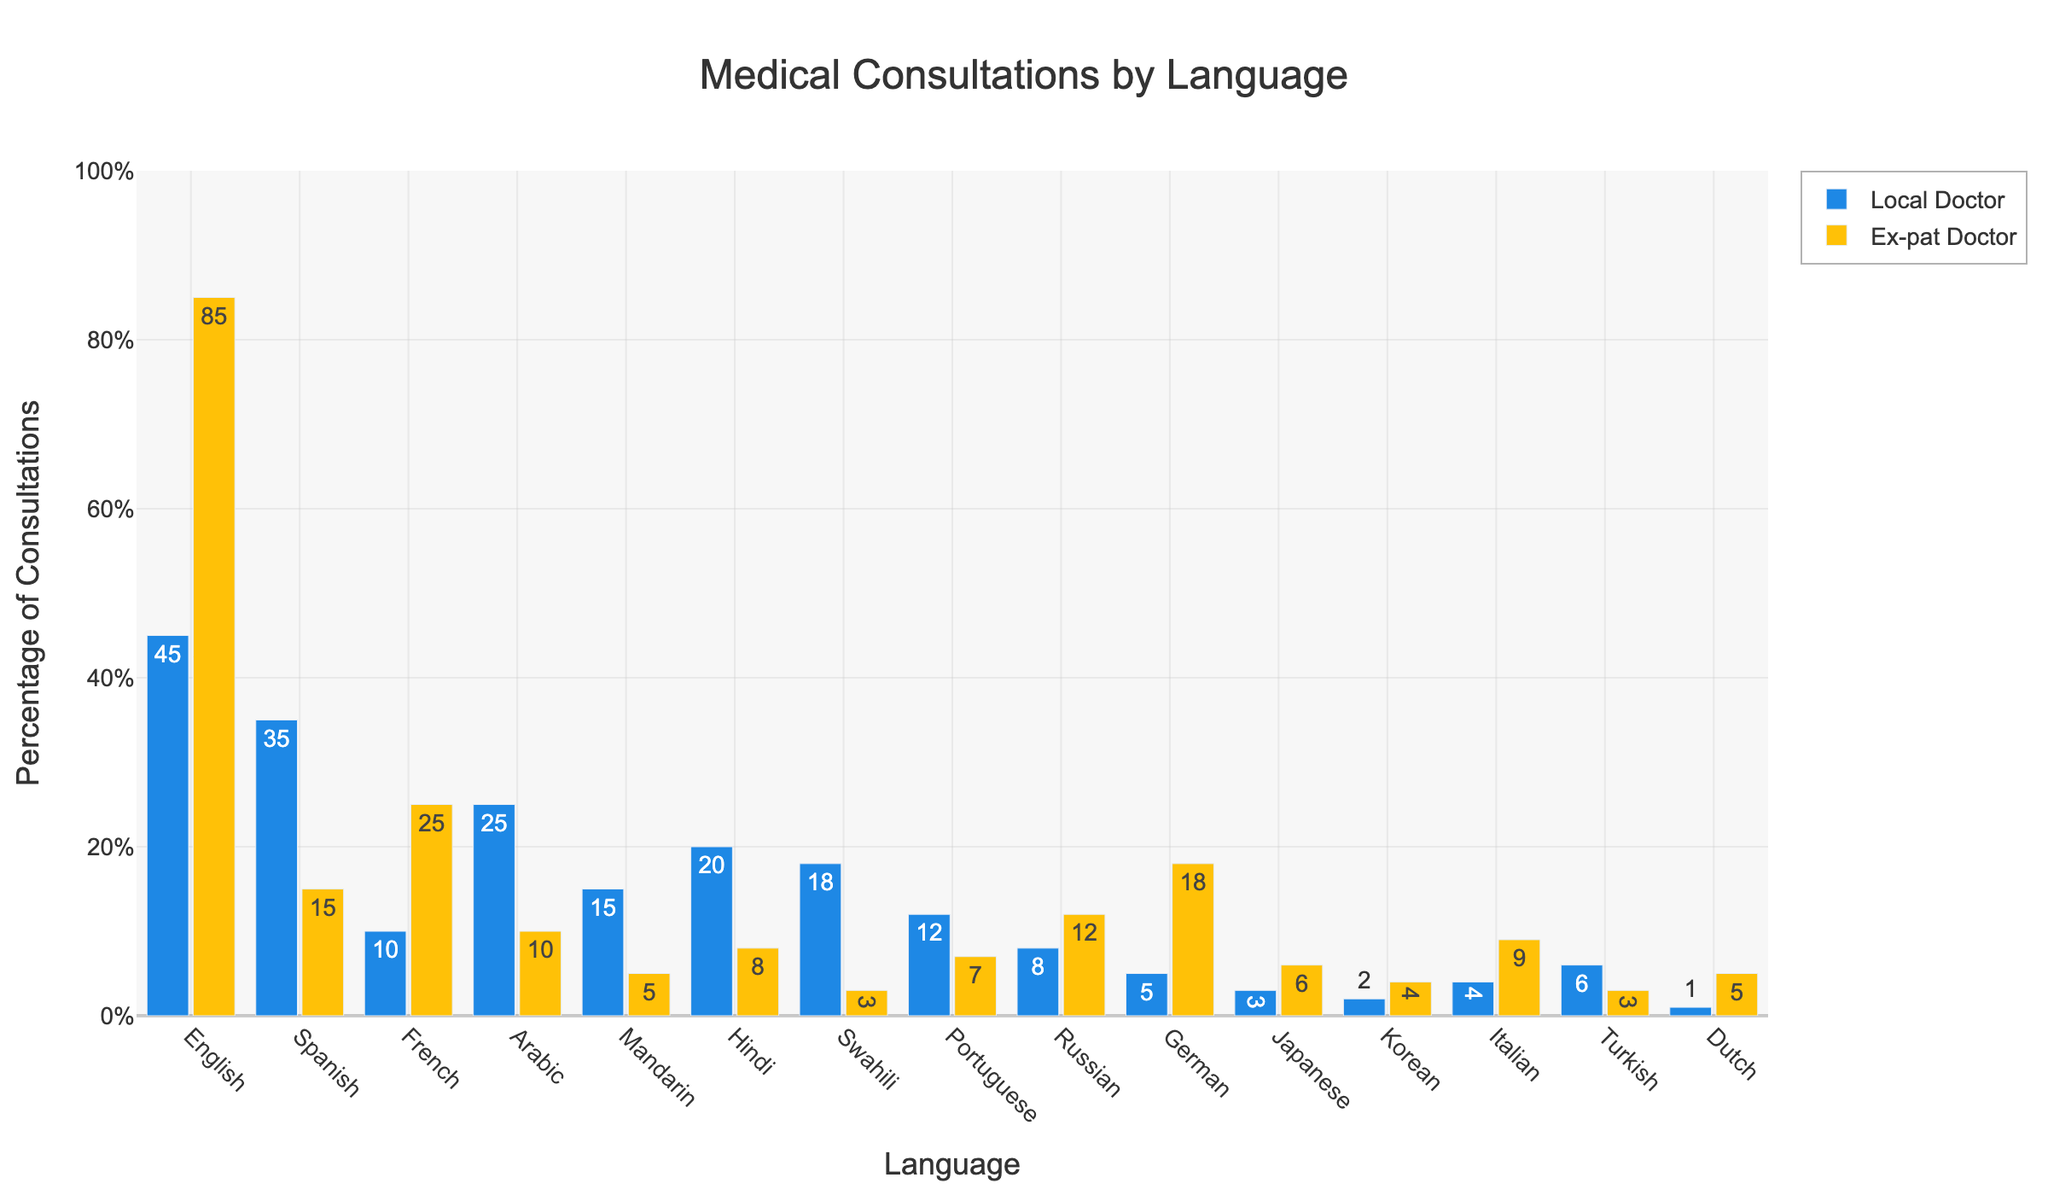What's the percentage difference in medical consultations conducted in English between Local and Ex-pat Doctors? To find the percentage difference, subtract the percentage of consultations done by Local Doctors from Ex-pat Doctors for English. That is 85% - 45% = 40%.
Answer: 40% Which language shows the highest percentage of consultations by Ex-pat Doctors? Look for the bar with the highest value under the 'Ex-pat Doctor' category. The highest percentage is seen in English with 85%.
Answer: English What is the combined percentage of consultations done in Spanish by both Local and Ex-pat Doctors? Add the percentages of consultations in Spanish conducted by Local Doctors (35%) and Ex-pat Doctors (15%). The combined percentage is 35% + 15% = 50%.
Answer: 50% Which doctor group conducts a higher percentage of consultations in French, and by how much? Compare the percentages for Local (10%) and Ex-pat (25%) Doctors in French. Ex-pat Doctors conduct a higher percentage. The difference is 25% - 10% = 15%.
Answer: Ex-pat by 15% What is the average percentage of consultations in Arabic for both Local and Ex-pat Doctors? Find the average of the two percentages (Local: 25%, Ex-pat: 10%). The average is (25% + 10%) / 2 = 17.5%.
Answer: 17.5% Which language has the smallest difference in consultation percentages between Local and Ex-pat Doctors? Check the differences for each language and find the smallest. Turkish has Local with 6% and Ex-pat with 3%, with a difference of 3%.
Answer: Turkish What is the ratio of medical consultations conducted in Hindi by Local Doctors to those conducted by Ex-pat Doctors? The percentage of consultations in Hindi is 20% for Local Doctors and 8% for Ex-pat Doctors. The ratio is 20/8 = 2.5.
Answer: 2.5 How many languages have a higher consultation percentage by Local Doctors compared to Ex-pat Doctors? Count the languages where the Local Doctor's percentage is higher than the Ex-pat Doctor's percentage. There are 10 such languages (Spanish, Arabic, Mandarin, Hindi, Swahili, Portuguese, Japanese, Korean, Turkish, Dutch).
Answer: 10 Which language consultation has the largest visual gap in percentage between Local and Ex-pat Doctors? By visually checking the bars, the largest gap is in English with Ex-pat (85%) vs Local (45%), a difference of 40%.
Answer: English 